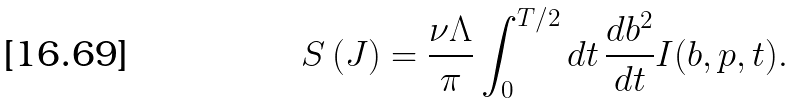<formula> <loc_0><loc_0><loc_500><loc_500>S \left ( J \right ) = \frac { \nu \Lambda } \pi \int _ { 0 } ^ { T / 2 } d t \, \frac { d b ^ { 2 } } { d t } I ( b , p , t ) .</formula> 